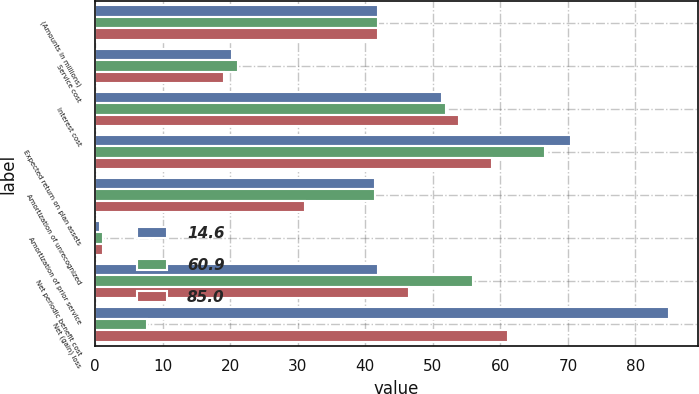<chart> <loc_0><loc_0><loc_500><loc_500><stacked_bar_chart><ecel><fcel>(Amounts in millions)<fcel>Service cost<fcel>Interest cost<fcel>Expected return on plan assets<fcel>Amortization of unrecognized<fcel>Amortization of prior service<fcel>Net periodic benefit cost<fcel>Net (gain) loss<nl><fcel>14.6<fcel>41.9<fcel>20.3<fcel>51.4<fcel>70.5<fcel>41.4<fcel>0.7<fcel>41.9<fcel>85<nl><fcel>60.9<fcel>41.9<fcel>21.1<fcel>52<fcel>66.6<fcel>41.4<fcel>1.2<fcel>55.9<fcel>7.6<nl><fcel>85<fcel>41.9<fcel>19.1<fcel>53.9<fcel>58.7<fcel>31.1<fcel>1.1<fcel>46.5<fcel>61.1<nl></chart> 